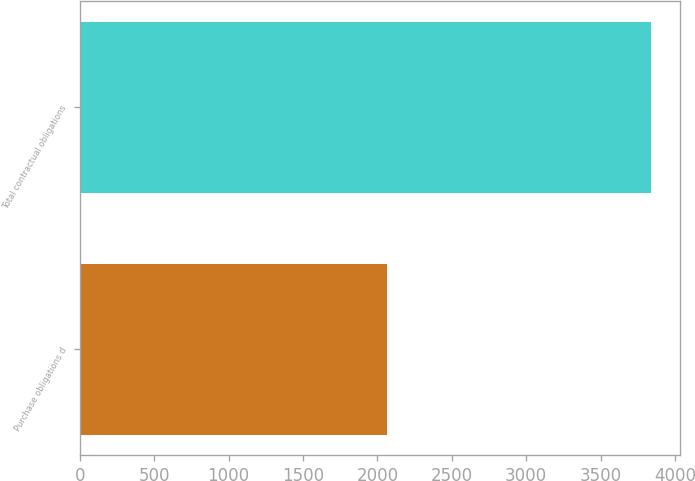Convert chart to OTSL. <chart><loc_0><loc_0><loc_500><loc_500><bar_chart><fcel>Purchase obligations d<fcel>Total contractual obligations<nl><fcel>2063<fcel>3839<nl></chart> 